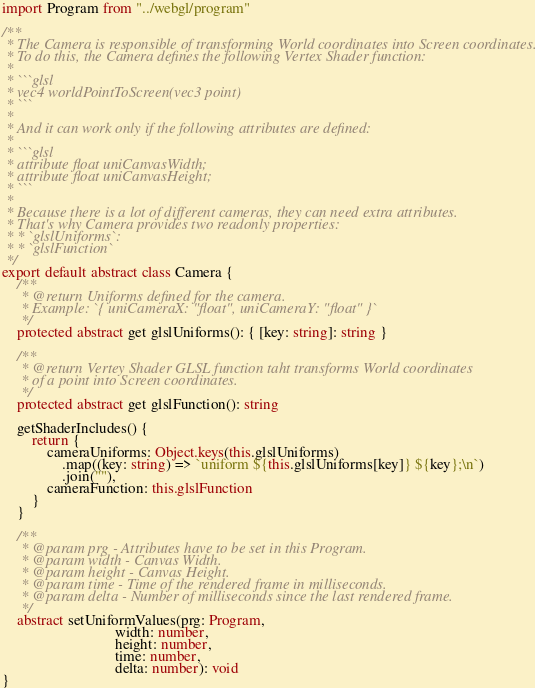<code> <loc_0><loc_0><loc_500><loc_500><_TypeScript_>import Program from "../webgl/program"

/**
 * The Camera is responsible of transforming World coordinates into Screen coordinates.
 * To do this, the Camera defines the following Vertex Shader function:
 *
 * ```glsl
 * vec4 worldPointToScreen(vec3 point)
 * ```
 *
 * And it can work only if the following attributes are defined:
 *
 * ```glsl
 * attribute float uniCanvasWidth;
 * attribute float uniCanvasHeight;
 * ```
 *
 * Because there is a lot of different cameras, they can need extra attributes.
 * That's why Camera provides two readonly properties:
 * * `glslUniforms`:
 * * `glslFunction`
 */
export default abstract class Camera {
    /**
     * @return Uniforms defined for the camera.
     * Example: `{ uniCameraX: "float", uniCameraY: "float" }`
     */
    protected abstract get glslUniforms(): { [key: string]: string }

    /**
     * @return Vertey Shader GLSL function taht transforms World coordinates
     * of a point into Screen coordinates.
     */
    protected abstract get glslFunction(): string

    getShaderIncludes() {
        return {
            cameraUniforms: Object.keys(this.glslUniforms)
                .map((key: string) => `uniform ${this.glslUniforms[key]} ${key};\n`)
                .join(""),
            cameraFunction: this.glslFunction
        }
    }

    /**
     * @param prg - Attributes have to be set in this Program.
     * @param width - Canvas Width.
     * @param height - Canvas Height.
     * @param time - Time of the rendered frame in milliseconds.
     * @param delta - Number of milliseconds since the last rendered frame.
     */
    abstract setUniformValues(prg: Program,
                              width: number,
                              height: number,
                              time: number,
                              delta: number): void
}
</code> 